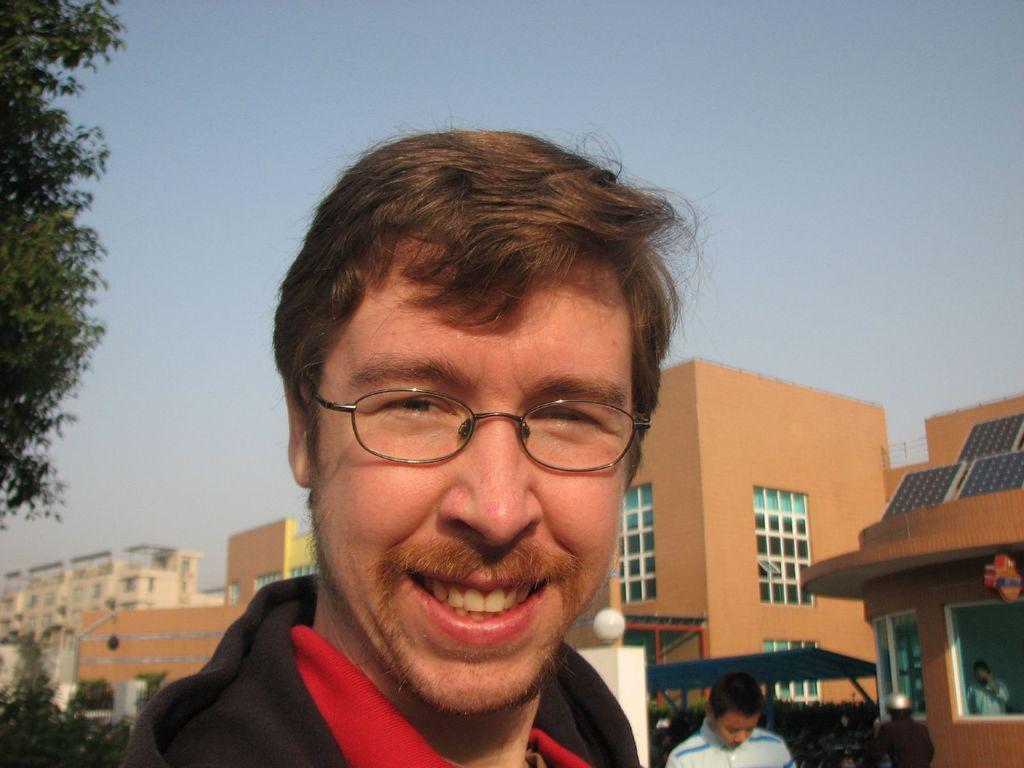Describe this image in one or two sentences. In this image I can see a person smiling, he is wearing spectacles. There is another person behind him. There are buildings and trees at the back. There is sky at the top. 